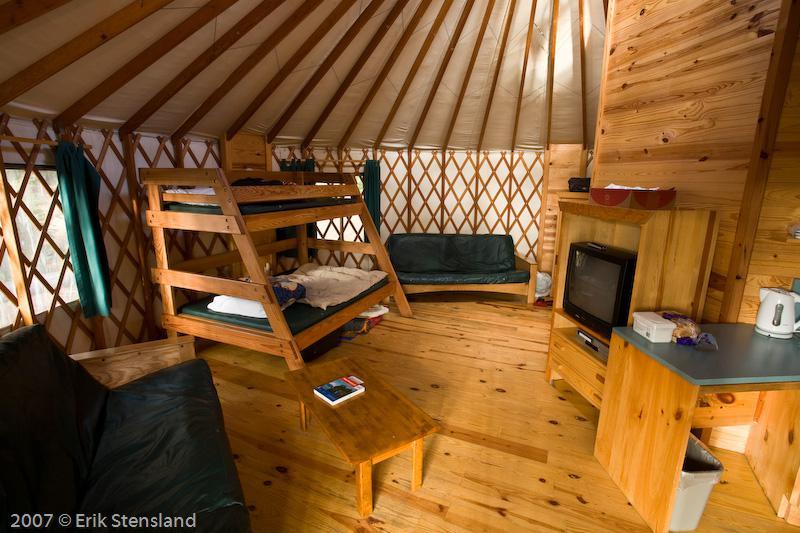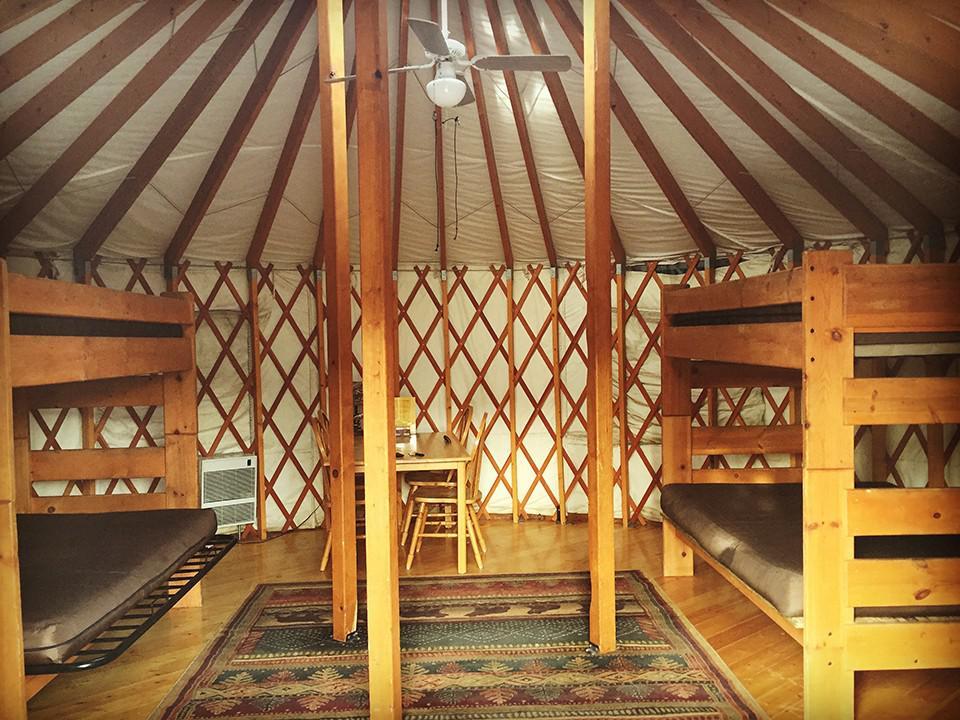The first image is the image on the left, the second image is the image on the right. Analyze the images presented: Is the assertion "The interior of a round house shows its fan-shaped ceiling and lattice walls." valid? Answer yes or no. Yes. The first image is the image on the left, the second image is the image on the right. For the images shown, is this caption "All of the images display the interior of the hut." true? Answer yes or no. Yes. 